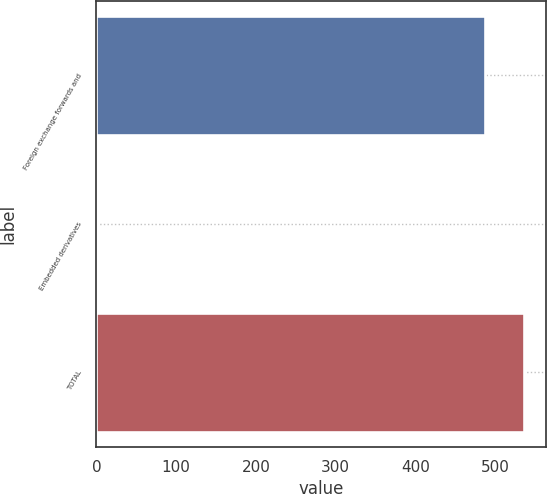<chart> <loc_0><loc_0><loc_500><loc_500><bar_chart><fcel>Foreign exchange forwards and<fcel>Embedded derivatives<fcel>TOTAL<nl><fcel>487<fcel>2<fcel>536.4<nl></chart> 